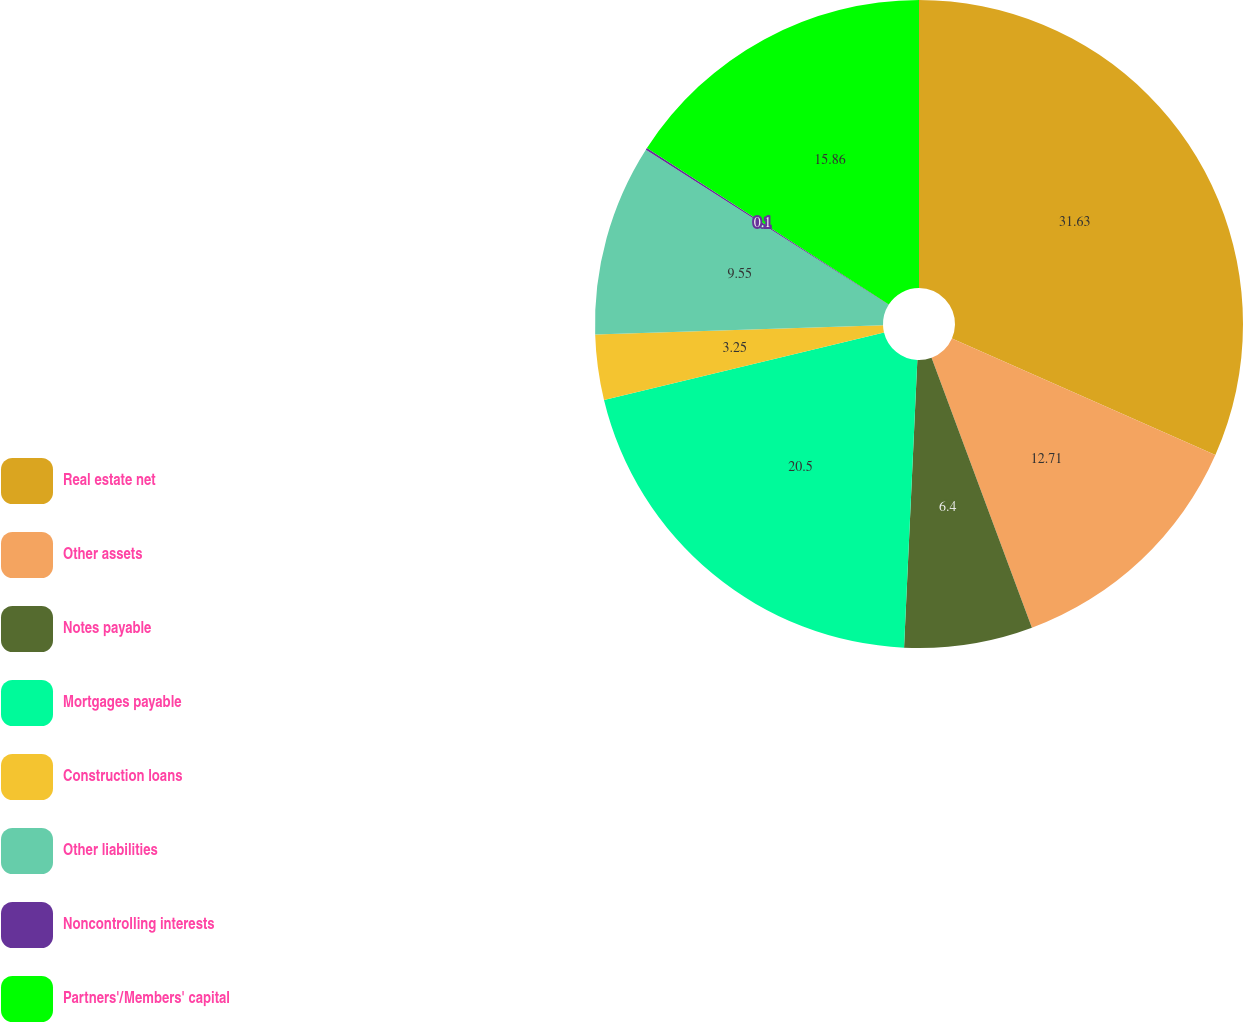Convert chart to OTSL. <chart><loc_0><loc_0><loc_500><loc_500><pie_chart><fcel>Real estate net<fcel>Other assets<fcel>Notes payable<fcel>Mortgages payable<fcel>Construction loans<fcel>Other liabilities<fcel>Noncontrolling interests<fcel>Partners'/Members' capital<nl><fcel>31.62%<fcel>12.71%<fcel>6.4%<fcel>20.5%<fcel>3.25%<fcel>9.55%<fcel>0.1%<fcel>15.86%<nl></chart> 